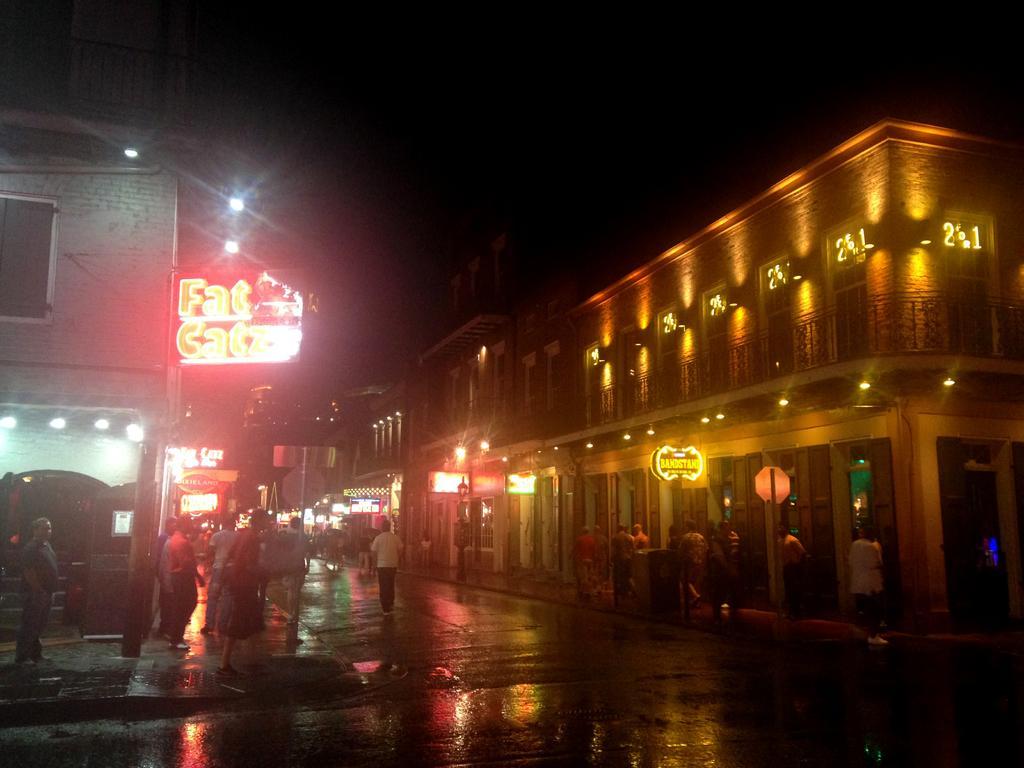How would you summarize this image in a sentence or two? In this image I see buildings and I see the lights on them and I see boards on which there are words written and I see number of people and I see the road and it is dark in the background. 